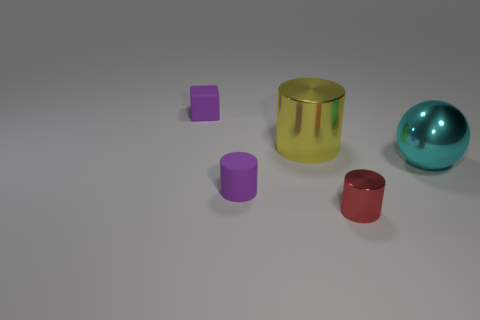Is the number of tiny purple matte cylinders that are to the left of the tiny matte cube greater than the number of big cyan things?
Provide a succinct answer. No. What number of rubber things are tiny blocks or tiny purple objects?
Your response must be concise. 2. How big is the thing that is both on the right side of the matte cube and on the left side of the yellow metallic thing?
Offer a terse response. Small. There is a tiny cylinder behind the red cylinder; is there a cylinder that is to the left of it?
Keep it short and to the point. No. How many cyan shiny things are to the left of the big cyan sphere?
Give a very brief answer. 0. What color is the tiny metallic thing that is the same shape as the big yellow object?
Ensure brevity in your answer.  Red. Is the material of the small cylinder behind the tiny red metal thing the same as the small purple thing that is behind the purple rubber cylinder?
Keep it short and to the point. Yes. There is a large metal cylinder; does it have the same color as the matte thing in front of the small cube?
Offer a terse response. No. There is a tiny thing that is left of the yellow metallic object and on the right side of the small purple matte cube; what shape is it?
Your response must be concise. Cylinder. How many tiny yellow matte objects are there?
Your answer should be compact. 0. 